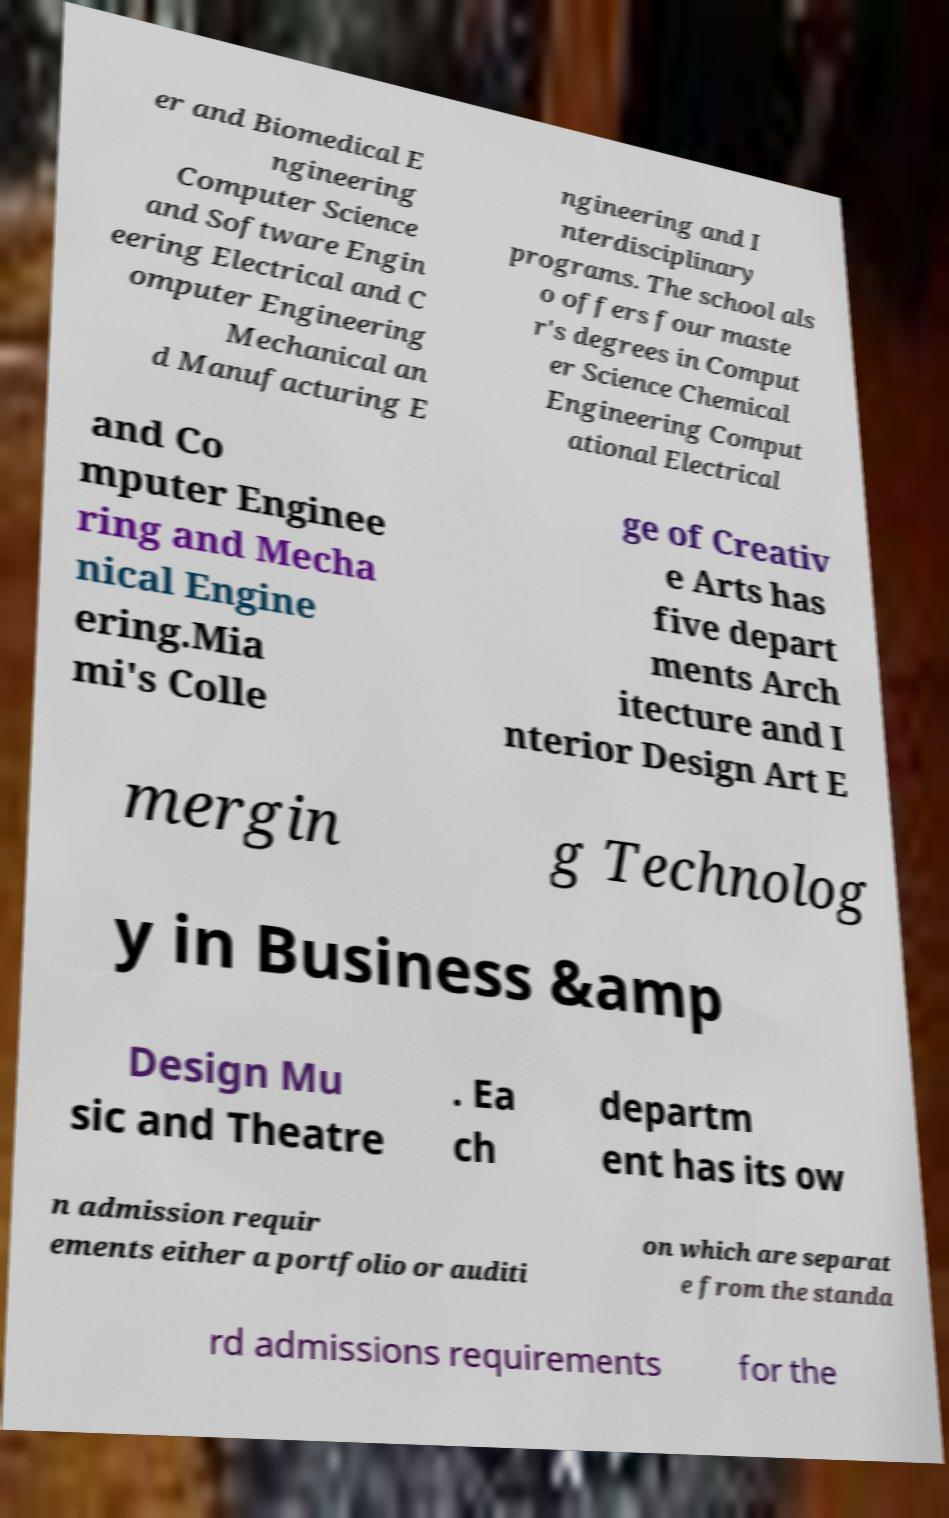Could you extract and type out the text from this image? er and Biomedical E ngineering Computer Science and Software Engin eering Electrical and C omputer Engineering Mechanical an d Manufacturing E ngineering and I nterdisciplinary programs. The school als o offers four maste r's degrees in Comput er Science Chemical Engineering Comput ational Electrical and Co mputer Enginee ring and Mecha nical Engine ering.Mia mi's Colle ge of Creativ e Arts has five depart ments Arch itecture and I nterior Design Art E mergin g Technolog y in Business &amp Design Mu sic and Theatre . Ea ch departm ent has its ow n admission requir ements either a portfolio or auditi on which are separat e from the standa rd admissions requirements for the 